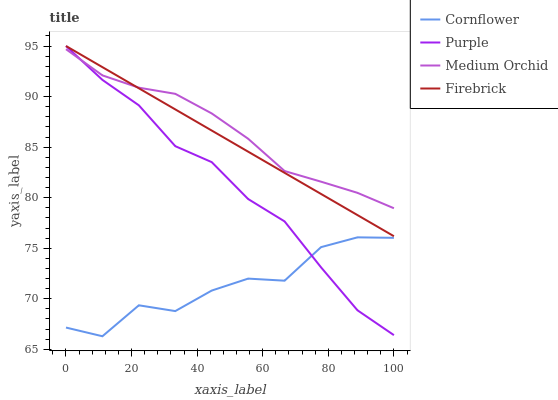Does Firebrick have the minimum area under the curve?
Answer yes or no. No. Does Firebrick have the maximum area under the curve?
Answer yes or no. No. Is Cornflower the smoothest?
Answer yes or no. No. Is Firebrick the roughest?
Answer yes or no. No. Does Firebrick have the lowest value?
Answer yes or no. No. Does Cornflower have the highest value?
Answer yes or no. No. Is Cornflower less than Medium Orchid?
Answer yes or no. Yes. Is Medium Orchid greater than Cornflower?
Answer yes or no. Yes. Does Cornflower intersect Medium Orchid?
Answer yes or no. No. 